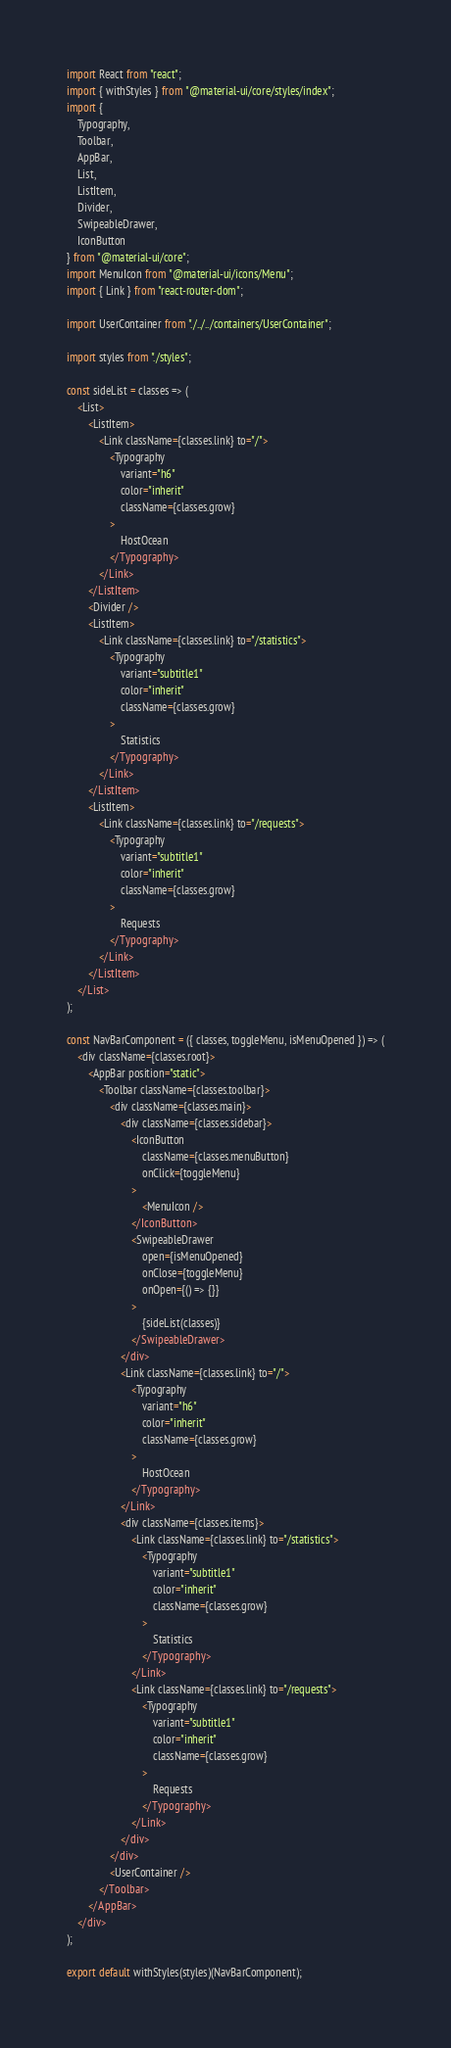<code> <loc_0><loc_0><loc_500><loc_500><_JavaScript_>import React from "react";
import { withStyles } from "@material-ui/core/styles/index";
import {
    Typography,
    Toolbar,
    AppBar,
    List,
    ListItem,
    Divider,
    SwipeableDrawer,
    IconButton
} from "@material-ui/core";
import MenuIcon from "@material-ui/icons/Menu";
import { Link } from "react-router-dom";

import UserContainer from "./../../containers/UserContainer";

import styles from "./styles";

const sideList = classes => (
    <List>
        <ListItem>
            <Link className={classes.link} to="/">
                <Typography
                    variant="h6"
                    color="inherit"
                    className={classes.grow}
                >
                    HostOcean
                </Typography>
            </Link>
        </ListItem>
        <Divider />
        <ListItem>
            <Link className={classes.link} to="/statistics">
                <Typography
                    variant="subtitle1"
                    color="inherit"
                    className={classes.grow}
                >
                    Statistics
                </Typography>
            </Link>
        </ListItem>
        <ListItem>
            <Link className={classes.link} to="/requests">
                <Typography
                    variant="subtitle1"
                    color="inherit"
                    className={classes.grow}
                >
                    Requests
                </Typography>
            </Link>
        </ListItem>
    </List>
);

const NavBarComponent = ({ classes, toggleMenu, isMenuOpened }) => (
    <div className={classes.root}>
        <AppBar position="static">
            <Toolbar className={classes.toolbar}>
                <div className={classes.main}>
                    <div className={classes.sidebar}>
                        <IconButton
                            className={classes.menuButton}
                            onClick={toggleMenu}
                        >
                            <MenuIcon />
                        </IconButton>
                        <SwipeableDrawer
                            open={isMenuOpened}
                            onClose={toggleMenu}
                            onOpen={() => {}}
                        >
                            {sideList(classes)}
                        </SwipeableDrawer>
                    </div>
                    <Link className={classes.link} to="/">
                        <Typography
                            variant="h6"
                            color="inherit"
                            className={classes.grow}
                        >
                            HostOcean
                        </Typography>
                    </Link>
                    <div className={classes.items}>
                        <Link className={classes.link} to="/statistics">
                            <Typography
                                variant="subtitle1"
                                color="inherit"
                                className={classes.grow}
                            >
                                Statistics
                            </Typography>
                        </Link>
                        <Link className={classes.link} to="/requests">
                            <Typography
                                variant="subtitle1"
                                color="inherit"
                                className={classes.grow}
                            >
                                Requests
                            </Typography>
                        </Link>
                    </div>
                </div>
                <UserContainer />
            </Toolbar>
        </AppBar>
    </div>
);

export default withStyles(styles)(NavBarComponent);
</code> 